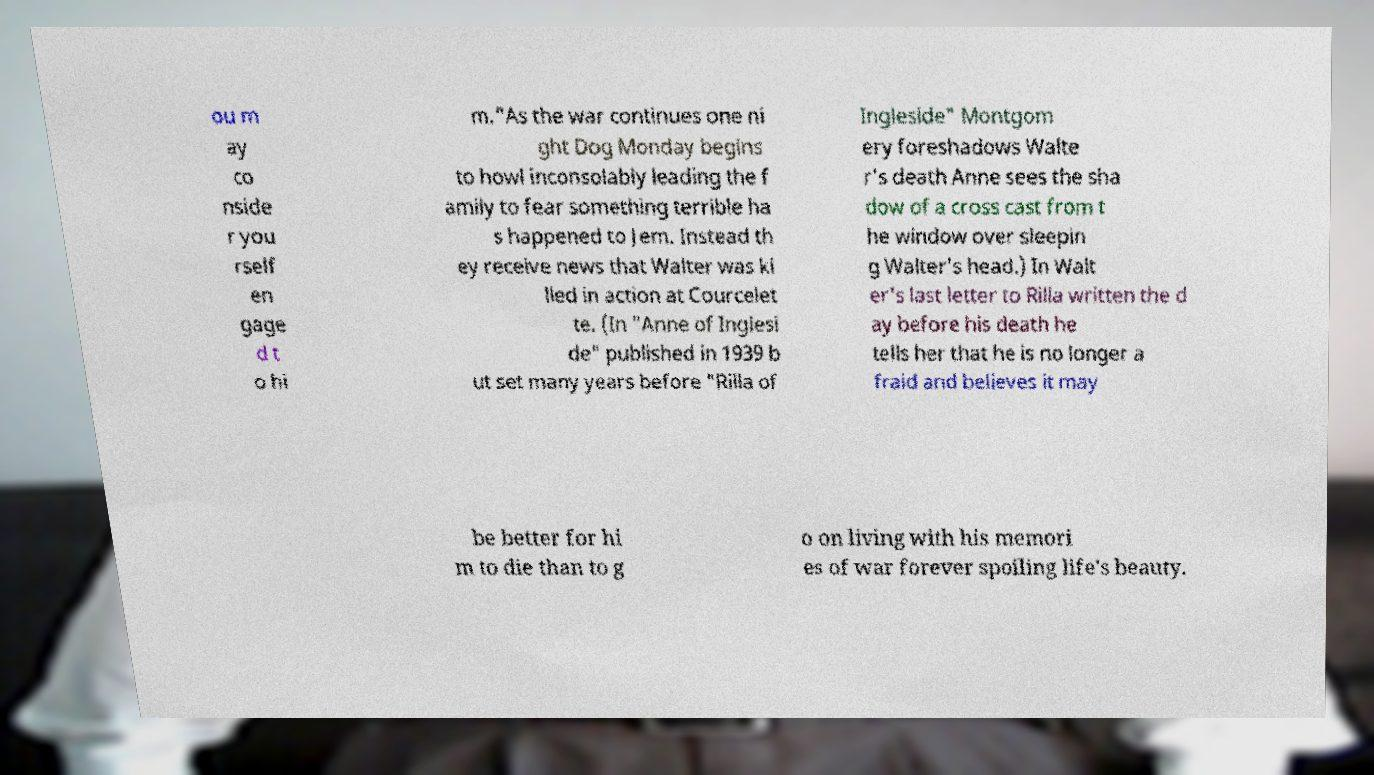For documentation purposes, I need the text within this image transcribed. Could you provide that? ou m ay co nside r you rself en gage d t o hi m."As the war continues one ni ght Dog Monday begins to howl inconsolably leading the f amily to fear something terrible ha s happened to Jem. Instead th ey receive news that Walter was ki lled in action at Courcelet te. (In "Anne of Inglesi de" published in 1939 b ut set many years before "Rilla of Ingleside" Montgom ery foreshadows Walte r's death Anne sees the sha dow of a cross cast from t he window over sleepin g Walter's head.) In Walt er's last letter to Rilla written the d ay before his death he tells her that he is no longer a fraid and believes it may be better for hi m to die than to g o on living with his memori es of war forever spoiling life's beauty. 